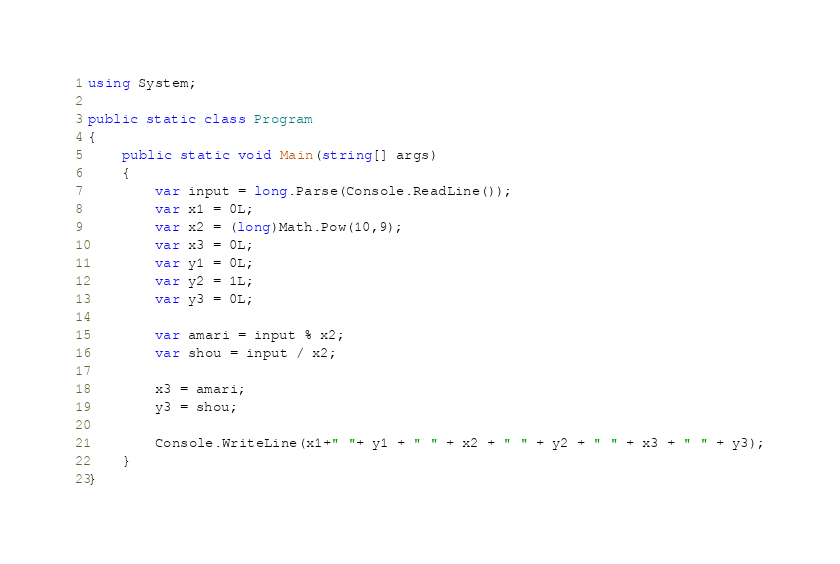<code> <loc_0><loc_0><loc_500><loc_500><_C#_>using System;

public static class Program
{
    public static void Main(string[] args)
    {
        var input = long.Parse(Console.ReadLine());
        var x1 = 0L;
        var x2 = (long)Math.Pow(10,9);
        var x3 = 0L;
        var y1 = 0L;
        var y2 = 1L;
        var y3 = 0L;

        var amari = input % x2;
        var shou = input / x2;

        x3 = amari;
        y3 = shou;

        Console.WriteLine(x1+" "+ y1 + " " + x2 + " " + y2 + " " + x3 + " " + y3);
    }
}</code> 